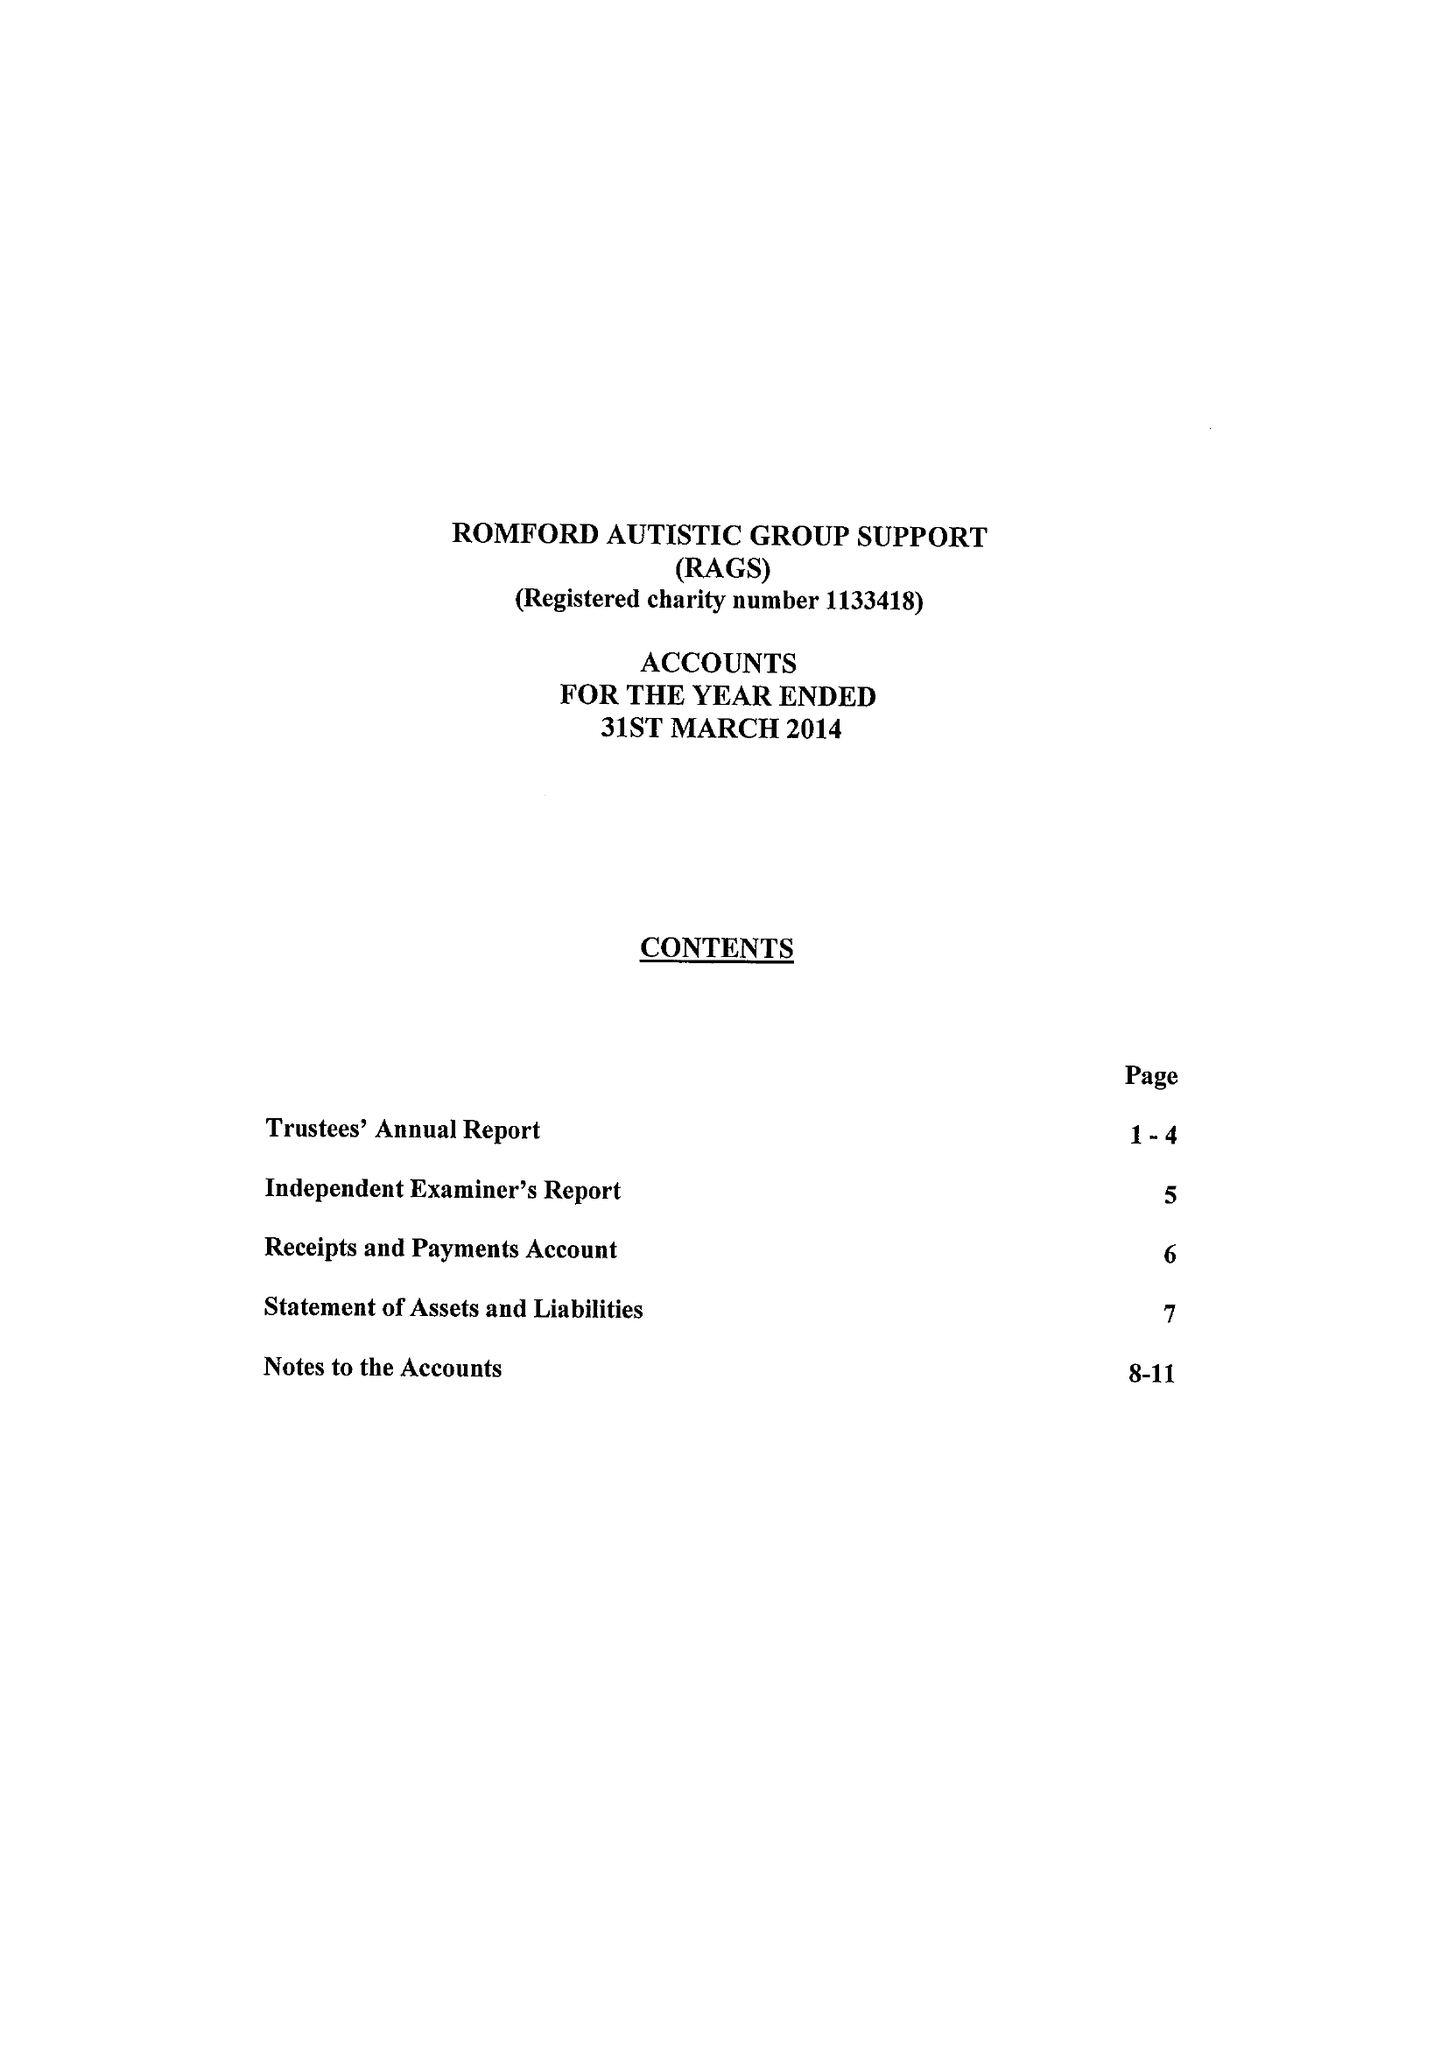What is the value for the income_annually_in_british_pounds?
Answer the question using a single word or phrase. 88777.00 